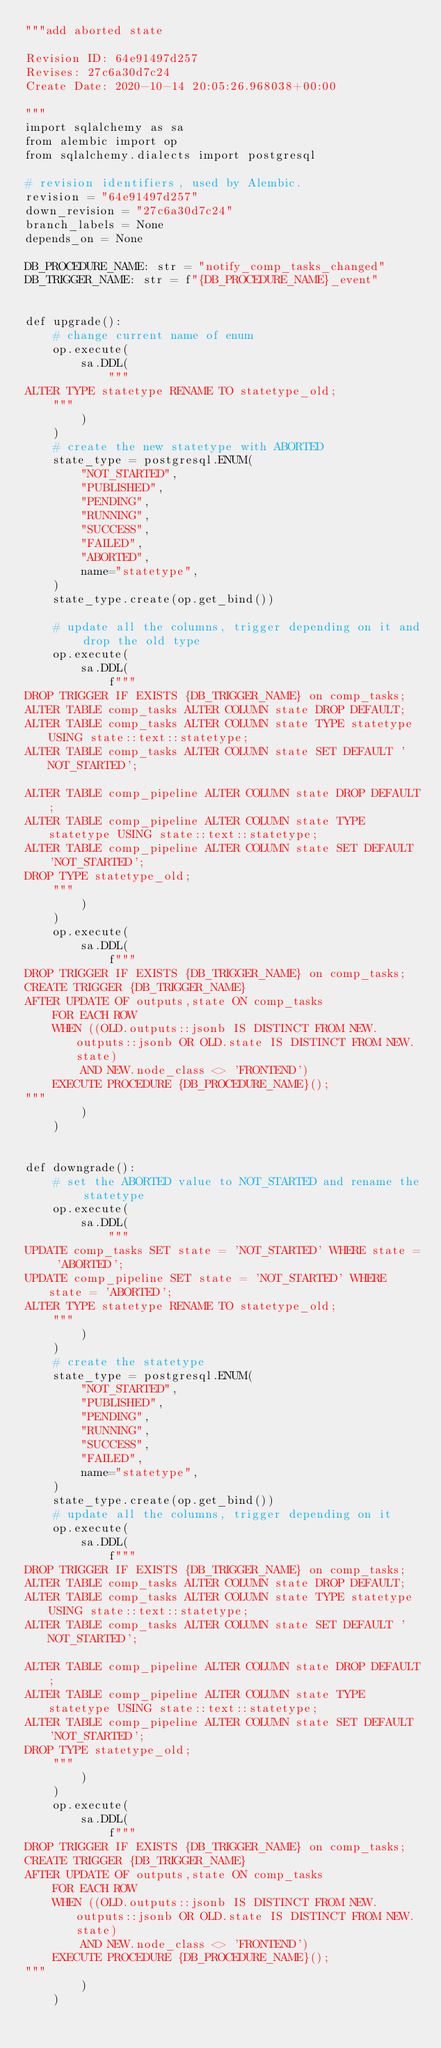<code> <loc_0><loc_0><loc_500><loc_500><_Python_>"""add aborted state

Revision ID: 64e91497d257
Revises: 27c6a30d7c24
Create Date: 2020-10-14 20:05:26.968038+00:00

"""
import sqlalchemy as sa
from alembic import op
from sqlalchemy.dialects import postgresql

# revision identifiers, used by Alembic.
revision = "64e91497d257"
down_revision = "27c6a30d7c24"
branch_labels = None
depends_on = None

DB_PROCEDURE_NAME: str = "notify_comp_tasks_changed"
DB_TRIGGER_NAME: str = f"{DB_PROCEDURE_NAME}_event"


def upgrade():
    # change current name of enum
    op.execute(
        sa.DDL(
            """
ALTER TYPE statetype RENAME TO statetype_old;
    """
        )
    )
    # create the new statetype with ABORTED
    state_type = postgresql.ENUM(
        "NOT_STARTED",
        "PUBLISHED",
        "PENDING",
        "RUNNING",
        "SUCCESS",
        "FAILED",
        "ABORTED",
        name="statetype",
    )
    state_type.create(op.get_bind())

    # update all the columns, trigger depending on it and drop the old type
    op.execute(
        sa.DDL(
            f"""
DROP TRIGGER IF EXISTS {DB_TRIGGER_NAME} on comp_tasks;
ALTER TABLE comp_tasks ALTER COLUMN state DROP DEFAULT;
ALTER TABLE comp_tasks ALTER COLUMN state TYPE statetype USING state::text::statetype;
ALTER TABLE comp_tasks ALTER COLUMN state SET DEFAULT 'NOT_STARTED';

ALTER TABLE comp_pipeline ALTER COLUMN state DROP DEFAULT;
ALTER TABLE comp_pipeline ALTER COLUMN state TYPE statetype USING state::text::statetype;
ALTER TABLE comp_pipeline ALTER COLUMN state SET DEFAULT 'NOT_STARTED';
DROP TYPE statetype_old;
    """
        )
    )
    op.execute(
        sa.DDL(
            f"""
DROP TRIGGER IF EXISTS {DB_TRIGGER_NAME} on comp_tasks;
CREATE TRIGGER {DB_TRIGGER_NAME}
AFTER UPDATE OF outputs,state ON comp_tasks
    FOR EACH ROW
    WHEN ((OLD.outputs::jsonb IS DISTINCT FROM NEW.outputs::jsonb OR OLD.state IS DISTINCT FROM NEW.state)
        AND NEW.node_class <> 'FRONTEND')
    EXECUTE PROCEDURE {DB_PROCEDURE_NAME}();
"""
        )
    )


def downgrade():
    # set the ABORTED value to NOT_STARTED and rename the statetype
    op.execute(
        sa.DDL(
            """
UPDATE comp_tasks SET state = 'NOT_STARTED' WHERE state = 'ABORTED';
UPDATE comp_pipeline SET state = 'NOT_STARTED' WHERE state = 'ABORTED';
ALTER TYPE statetype RENAME TO statetype_old;
    """
        )
    )
    # create the statetype
    state_type = postgresql.ENUM(
        "NOT_STARTED",
        "PUBLISHED",
        "PENDING",
        "RUNNING",
        "SUCCESS",
        "FAILED",
        name="statetype",
    )
    state_type.create(op.get_bind())
    # update all the columns, trigger depending on it
    op.execute(
        sa.DDL(
            f"""
DROP TRIGGER IF EXISTS {DB_TRIGGER_NAME} on comp_tasks;
ALTER TABLE comp_tasks ALTER COLUMN state DROP DEFAULT;
ALTER TABLE comp_tasks ALTER COLUMN state TYPE statetype USING state::text::statetype;
ALTER TABLE comp_tasks ALTER COLUMN state SET DEFAULT 'NOT_STARTED';

ALTER TABLE comp_pipeline ALTER COLUMN state DROP DEFAULT;
ALTER TABLE comp_pipeline ALTER COLUMN state TYPE statetype USING state::text::statetype;
ALTER TABLE comp_pipeline ALTER COLUMN state SET DEFAULT 'NOT_STARTED';
DROP TYPE statetype_old;
    """
        )
    )
    op.execute(
        sa.DDL(
            f"""
DROP TRIGGER IF EXISTS {DB_TRIGGER_NAME} on comp_tasks;
CREATE TRIGGER {DB_TRIGGER_NAME}
AFTER UPDATE OF outputs,state ON comp_tasks
    FOR EACH ROW
    WHEN ((OLD.outputs::jsonb IS DISTINCT FROM NEW.outputs::jsonb OR OLD.state IS DISTINCT FROM NEW.state)
        AND NEW.node_class <> 'FRONTEND')
    EXECUTE PROCEDURE {DB_PROCEDURE_NAME}();
"""
        )
    )
</code> 